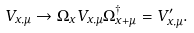Convert formula to latex. <formula><loc_0><loc_0><loc_500><loc_500>V _ { x , \mu } \rightarrow \Omega _ { x } V _ { x , \mu } \Omega _ { x + \mu } ^ { \dagger } = V _ { x , \mu } ^ { \prime } .</formula> 